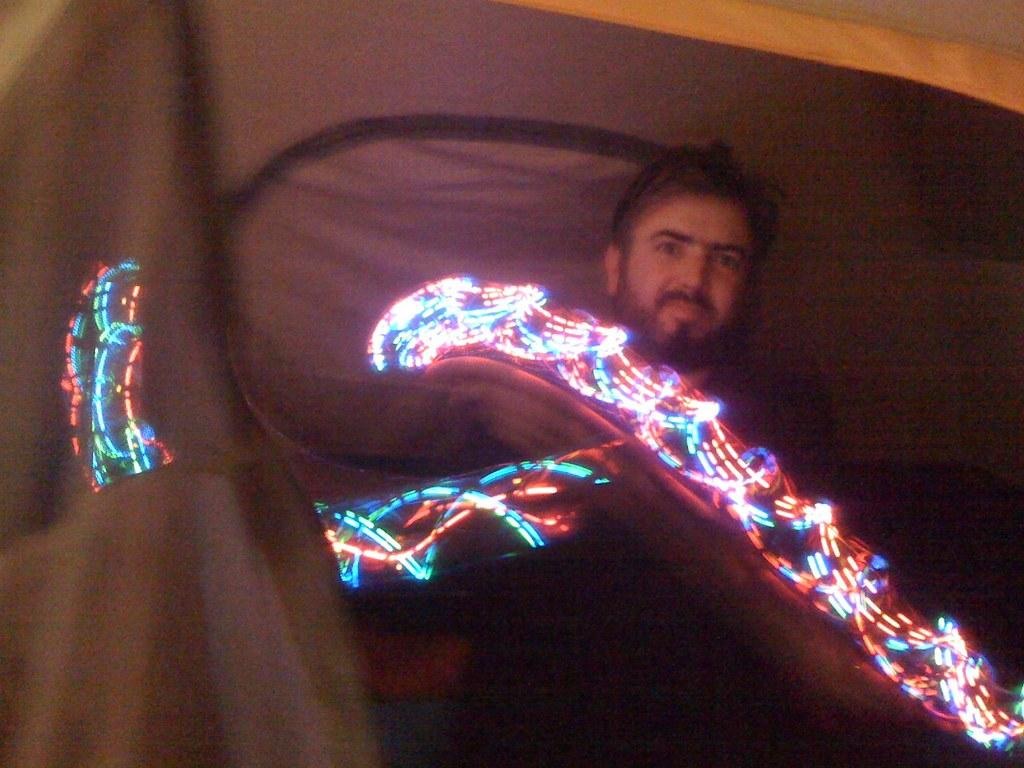What is: What is the main subject in the center of the picture? There is a man standing in the center of the picture. What can be seen in the foreground of the image? There are lights in the foreground of the image. What is located behind the man in the picture? There is a curtain behind the man. What type of cherries are hanging from the end of the curtain in the image? There are no cherries present in the image, and the curtain does not have any hanging from it. 